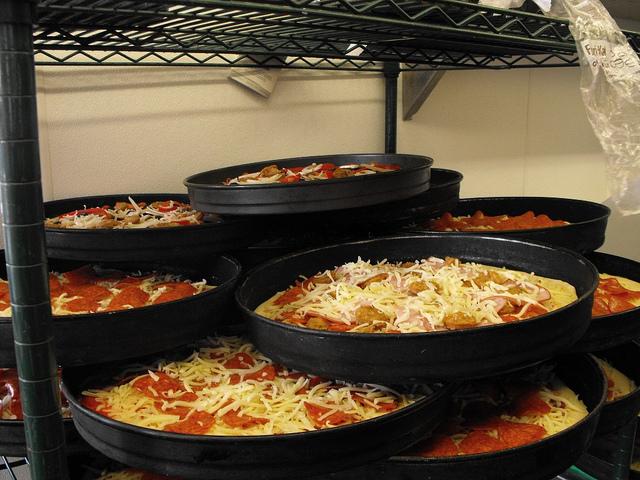What type of cooking pan is this?
Give a very brief answer. Pizza. How many pizzas are in the photo?
Concise answer only. 11. What is the most Americanized thing in this picture?
Quick response, please. Pizza. Is there cheese on the pizza?
Be succinct. Yes. What number of cheese shreds are in this picture?
Concise answer only. Lot. 